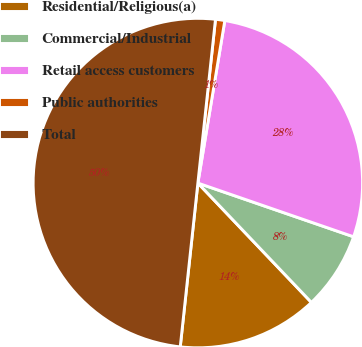Convert chart. <chart><loc_0><loc_0><loc_500><loc_500><pie_chart><fcel>Residential/Religious(a)<fcel>Commercial/Industrial<fcel>Retail access customers<fcel>Public authorities<fcel>Total<nl><fcel>13.81%<fcel>7.61%<fcel>27.67%<fcel>0.91%<fcel>50.0%<nl></chart> 